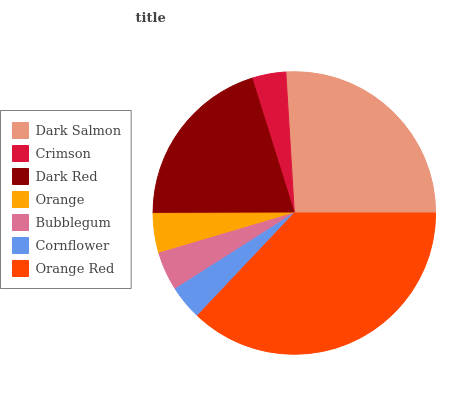Is Crimson the minimum?
Answer yes or no. Yes. Is Orange Red the maximum?
Answer yes or no. Yes. Is Dark Red the minimum?
Answer yes or no. No. Is Dark Red the maximum?
Answer yes or no. No. Is Dark Red greater than Crimson?
Answer yes or no. Yes. Is Crimson less than Dark Red?
Answer yes or no. Yes. Is Crimson greater than Dark Red?
Answer yes or no. No. Is Dark Red less than Crimson?
Answer yes or no. No. Is Orange the high median?
Answer yes or no. Yes. Is Orange the low median?
Answer yes or no. Yes. Is Dark Salmon the high median?
Answer yes or no. No. Is Crimson the low median?
Answer yes or no. No. 